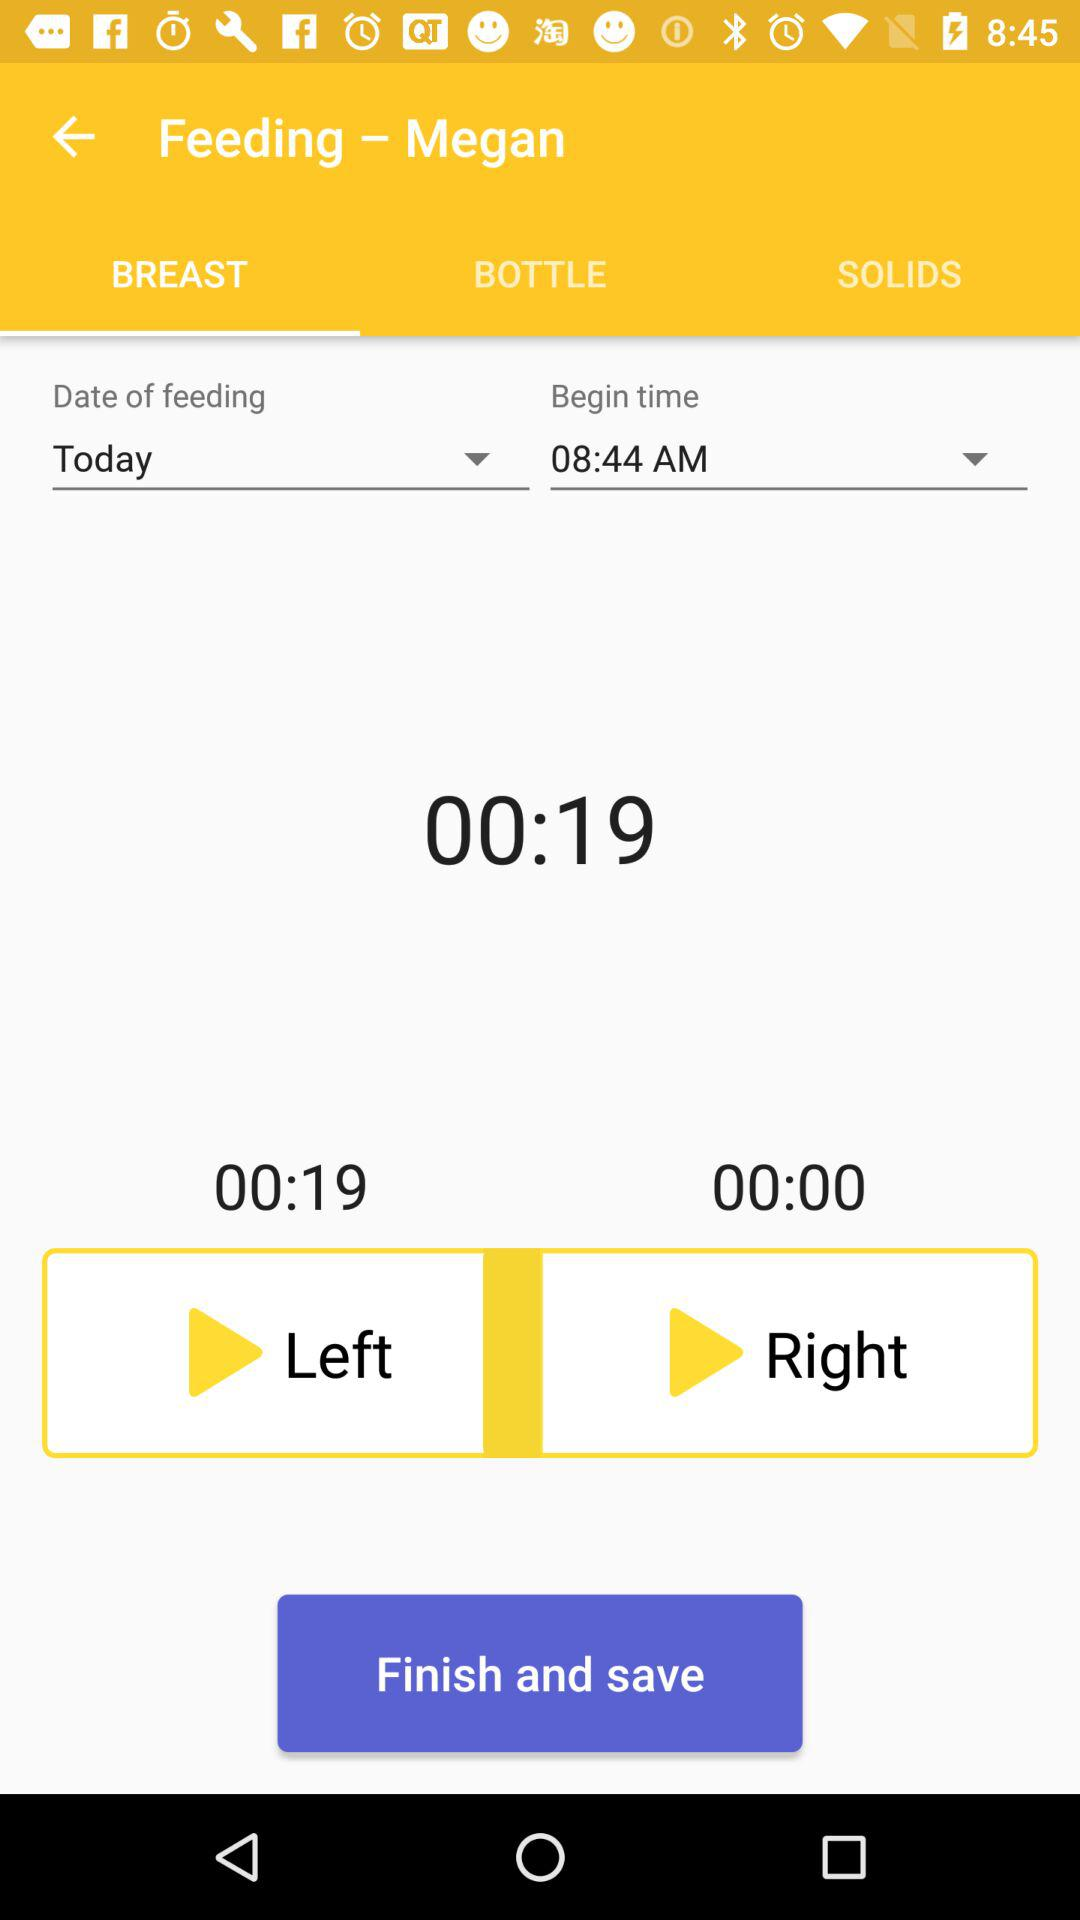What is the date of the feeding? The date of the feeding is today. 